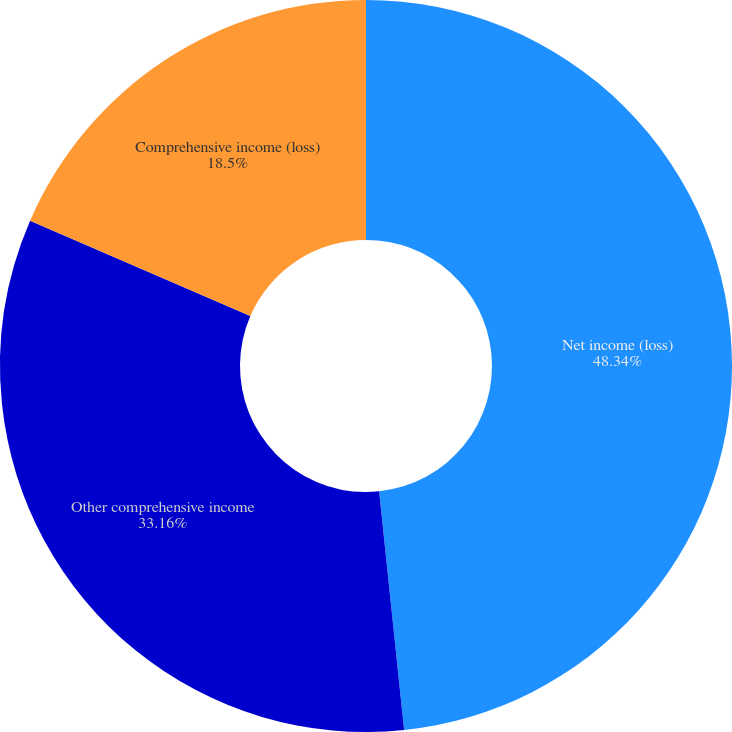Convert chart to OTSL. <chart><loc_0><loc_0><loc_500><loc_500><pie_chart><fcel>Net income (loss)<fcel>Other comprehensive income<fcel>Comprehensive income (loss)<nl><fcel>48.34%<fcel>33.16%<fcel>18.5%<nl></chart> 